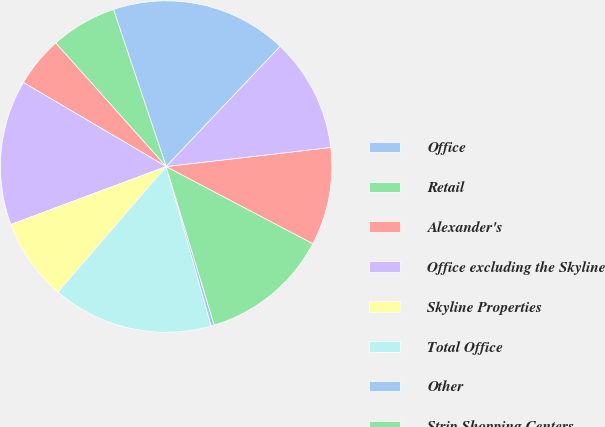<chart> <loc_0><loc_0><loc_500><loc_500><pie_chart><fcel>Office<fcel>Retail<fcel>Alexander's<fcel>Office excluding the Skyline<fcel>Skyline Properties<fcel>Total Office<fcel>Other<fcel>Strip Shopping Centers<fcel>Regional Malls<fcel>The Mart<nl><fcel>17.23%<fcel>6.46%<fcel>4.92%<fcel>14.15%<fcel>8.0%<fcel>15.69%<fcel>0.31%<fcel>12.61%<fcel>9.54%<fcel>11.08%<nl></chart> 